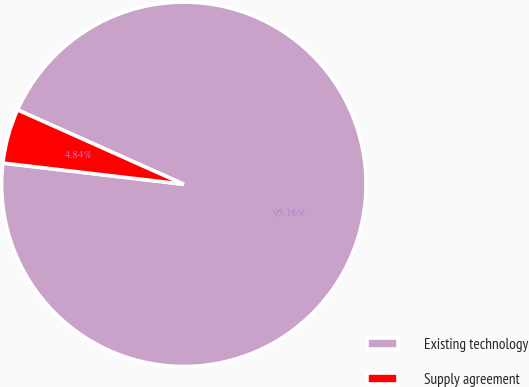Convert chart to OTSL. <chart><loc_0><loc_0><loc_500><loc_500><pie_chart><fcel>Existing technology<fcel>Supply agreement<nl><fcel>95.16%<fcel>4.84%<nl></chart> 